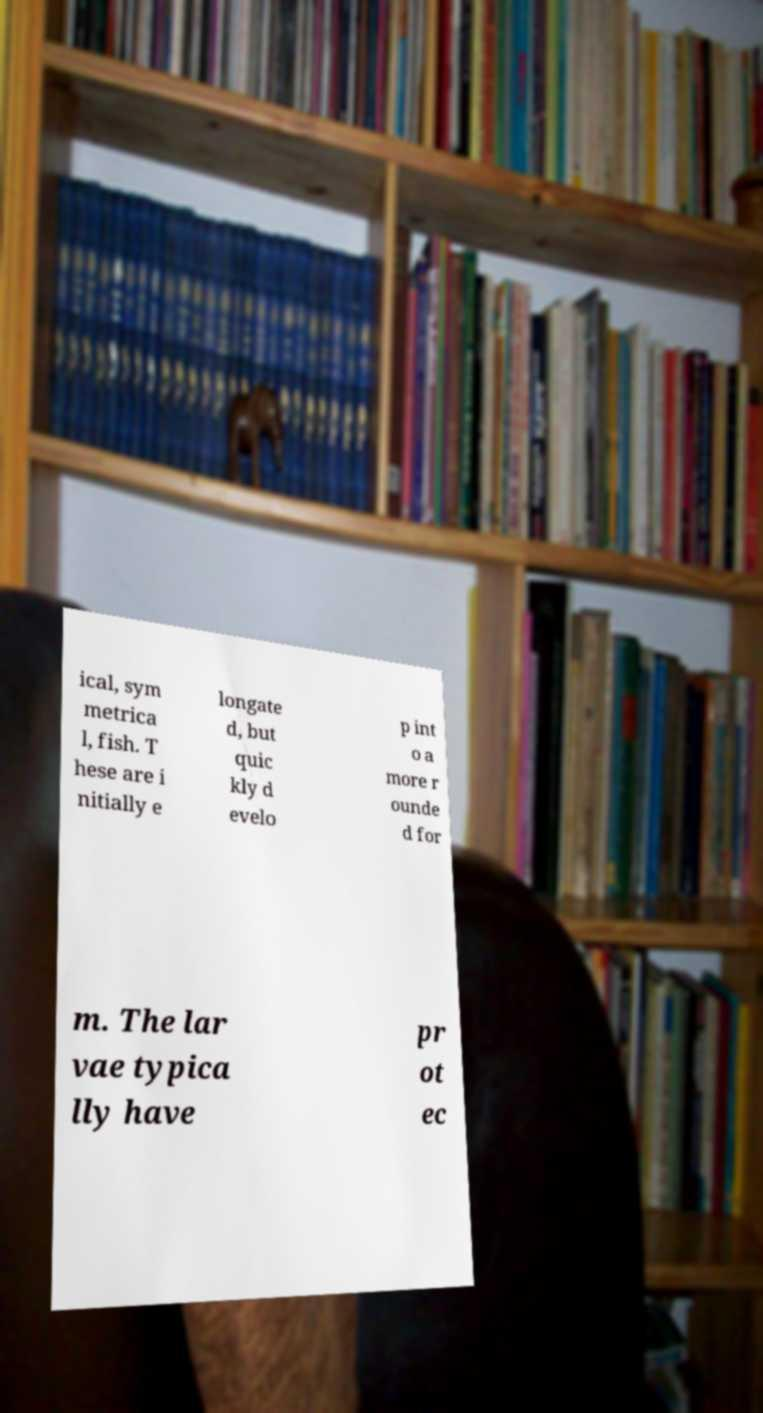Please identify and transcribe the text found in this image. ical, sym metrica l, fish. T hese are i nitially e longate d, but quic kly d evelo p int o a more r ounde d for m. The lar vae typica lly have pr ot ec 